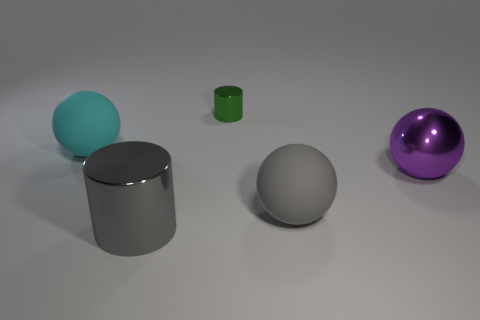Subtract all matte balls. How many balls are left? 1 Add 3 large gray metallic cylinders. How many objects exist? 8 Subtract all cyan balls. How many balls are left? 2 Subtract all spheres. How many objects are left? 2 Subtract 2 cylinders. How many cylinders are left? 0 Subtract all green cylinders. Subtract all purple cubes. How many cylinders are left? 1 Subtract all large yellow shiny things. Subtract all tiny green shiny cylinders. How many objects are left? 4 Add 4 tiny green metallic cylinders. How many tiny green metallic cylinders are left? 5 Add 2 big red balls. How many big red balls exist? 2 Subtract 0 yellow blocks. How many objects are left? 5 